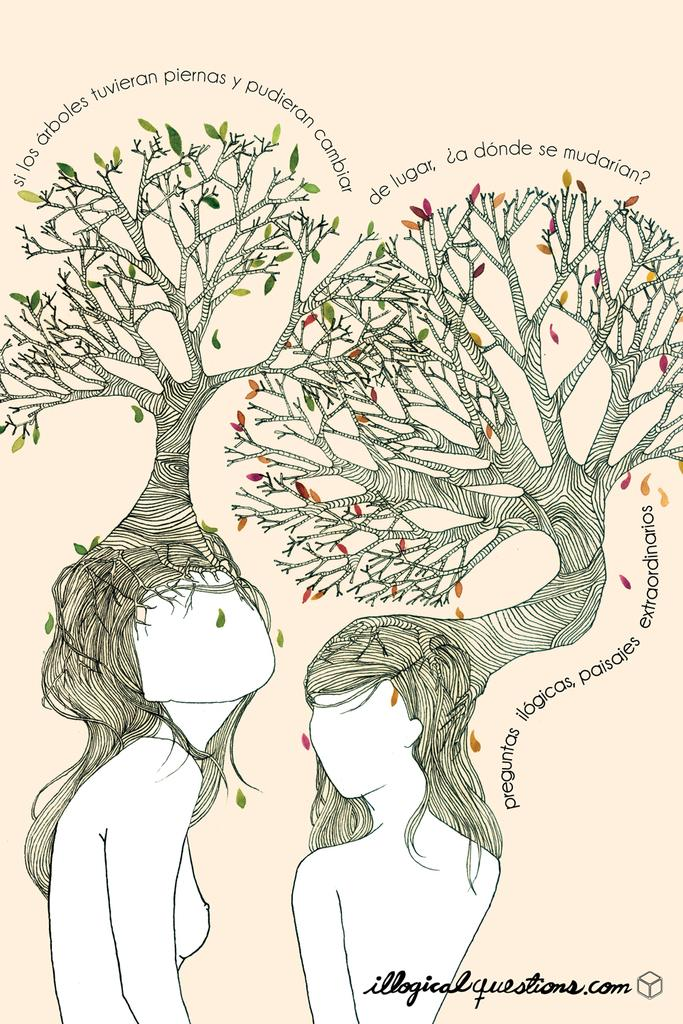How many people are in the image? There are two persons in the image. What else can be seen in the image besides the people? There is text and trees visible in the image. What is the color of the background in the image? The background of the image is cream-colored. Can you tell if the image has been altered or edited? Yes, the image appears to be an edited photo. Are there any cherries hanging from the trees in the image? There is no mention of cherries or any fruit in the image; only trees are present. Can you see a rabbit hopping through the grass in the image? There is no rabbit or grass visible in the image; only trees and a cream-colored background are present. 